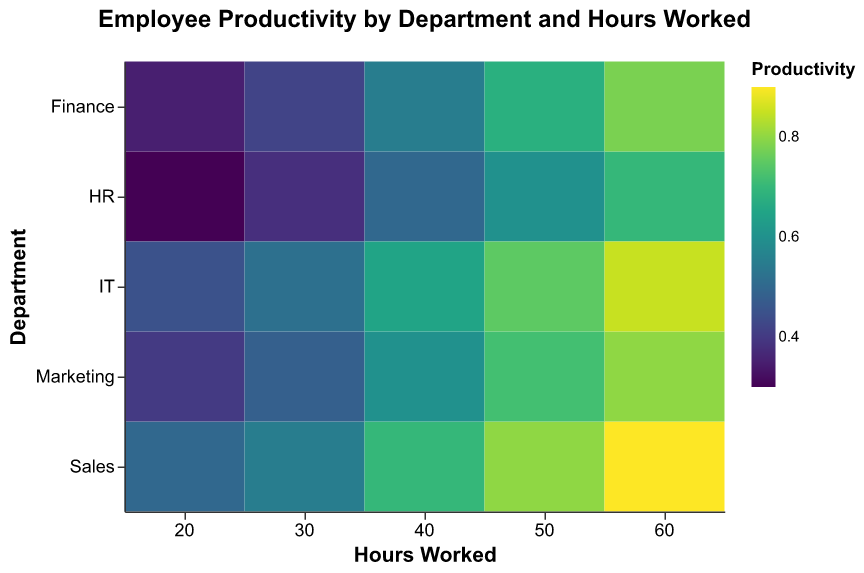What is the title of the heatmap? The title of the heatmap is located at the top and reads, "Employee Productivity by Department and Hours Worked."
Answer: Employee Productivity by Department and Hours Worked Which department has the highest productivity at 60 hours worked? Each cell in the heatmap represents productivity. From the cell with the highest color intensity at 60 hours worked, the highest productivity value is 0.90 for the Sales department.
Answer: Sales What is the productivity value for HR employees working 20 hours? Locate the cell intersection of HR and 20 hours. The corresponding cell shows the productivity value as 0.30.
Answer: 0.30 Which department has the lowest productivity at 40 hours? Check the cells in the column for 40 hours; HR has a productivity of 0.50, which is the lowest among all departments for this hour range.
Answer: HR Calculate the average productivity for Sales employees across all hours worked. Add up the productivity values for Sales (0.50, 0.55, 0.70, 0.80, 0.90) and divide by the number of points (5). The calculation is (0.50+0.55+0.70+0.80+0.90) / 5 = 3.45 / 5 = 0.69.
Answer: 0.69 How does the productivity of IT employees at 40 hours compare to Finance employees at the same hours? Locate the cells for IT and Finance at 40 hours. The IT productivity is 0.65, and the Finance productivity is 0.55. Compare these values: 0.65 is greater than 0.55.
Answer: IT is higher Which department shows the greatest increase in productivity from 20 to 60 hours worked? Compare the productivity values at 20 and 60 hours for each department. The increases are: Sales (0.90-0.50=0.40), Marketing (0.80-0.40=0.40), HR (0.70-0.30=0.40), IT (0.85-0.45=0.40), Finance (0.78-0.35=0.43). The greatest increase is in Finance.
Answer: Finance How does the productivity of Marketing employees at 50 hours compare to HR employees at 60 hours? Locate the cells for Marketing at 50 hours and HR at 60 hours. The Marketing productivity is 0.72 and HR's is 0.70. Compare these values: 0.72 is slightly higher than 0.70.
Answer: Marketing is higher 